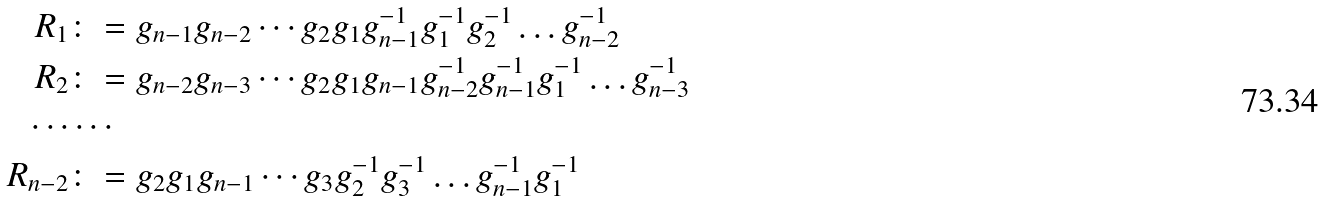<formula> <loc_0><loc_0><loc_500><loc_500>R _ { 1 } & \colon = g _ { n - 1 } g _ { n - 2 } \cdots g _ { 2 } g _ { 1 } g _ { n - 1 } ^ { - 1 } g _ { 1 } ^ { - 1 } g _ { 2 } ^ { - 1 } \dots g _ { n - 2 } ^ { - 1 } \\ R _ { 2 } & \colon = g _ { n - 2 } g _ { n - 3 } \cdots g _ { 2 } g _ { 1 } g _ { n - 1 } g _ { n - 2 } ^ { - 1 } g _ { n - 1 } ^ { - 1 } g _ { 1 } ^ { - 1 } \dots g _ { n - 3 } ^ { - 1 } \\ \cdots & \cdots \\ R _ { n - 2 } & \colon = g _ { 2 } g _ { 1 } g _ { n - 1 } \cdots g _ { 3 } g _ { 2 } ^ { - 1 } g _ { 3 } ^ { - 1 } \dots g _ { n - 1 } ^ { - 1 } g _ { 1 } ^ { - 1 }</formula> 